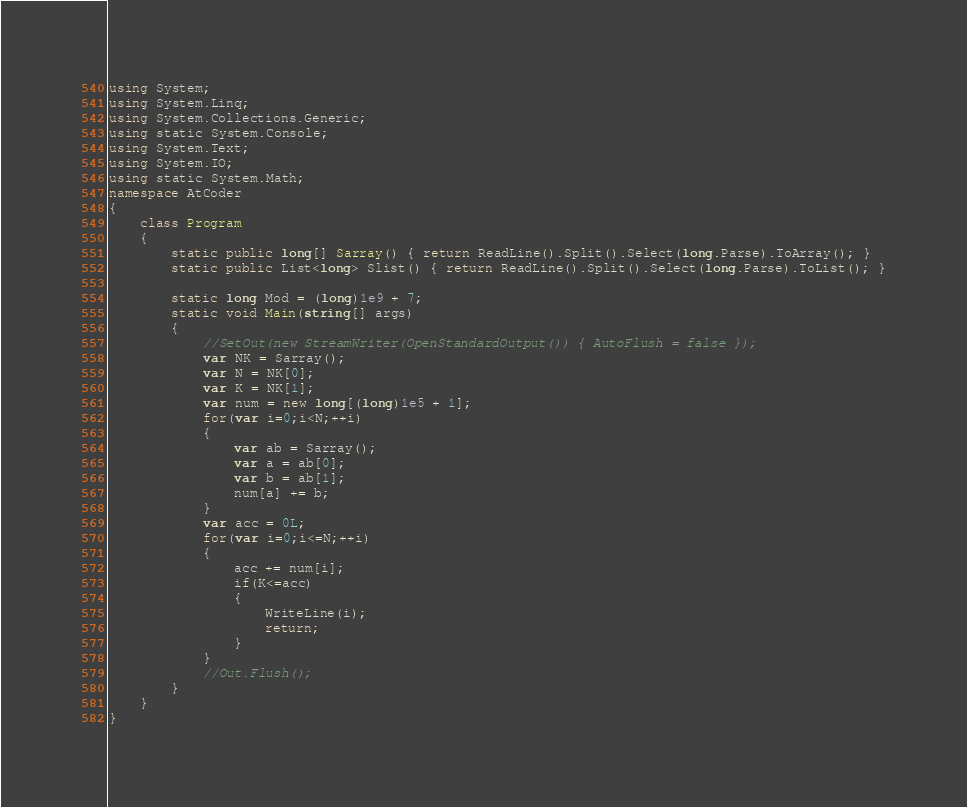Convert code to text. <code><loc_0><loc_0><loc_500><loc_500><_C#_>using System;
using System.Linq;
using System.Collections.Generic;
using static System.Console;
using System.Text;
using System.IO;
using static System.Math;
namespace AtCoder
{
    class Program
    {
        static public long[] Sarray() { return ReadLine().Split().Select(long.Parse).ToArray(); }
        static public List<long> Slist() { return ReadLine().Split().Select(long.Parse).ToList(); }

        static long Mod = (long)1e9 + 7;
        static void Main(string[] args)
        {
            //SetOut(new StreamWriter(OpenStandardOutput()) { AutoFlush = false });
            var NK = Sarray();
            var N = NK[0];
            var K = NK[1];
            var num = new long[(long)1e5 + 1];
            for(var i=0;i<N;++i)
            {
                var ab = Sarray();
                var a = ab[0];
                var b = ab[1];
                num[a] += b;
            }
            var acc = 0L;
            for(var i=0;i<=N;++i)
            {
                acc += num[i];
                if(K<=acc)
                {
                    WriteLine(i);
                    return;
                }
            }
            //Out.Flush();
        }
    }
}</code> 